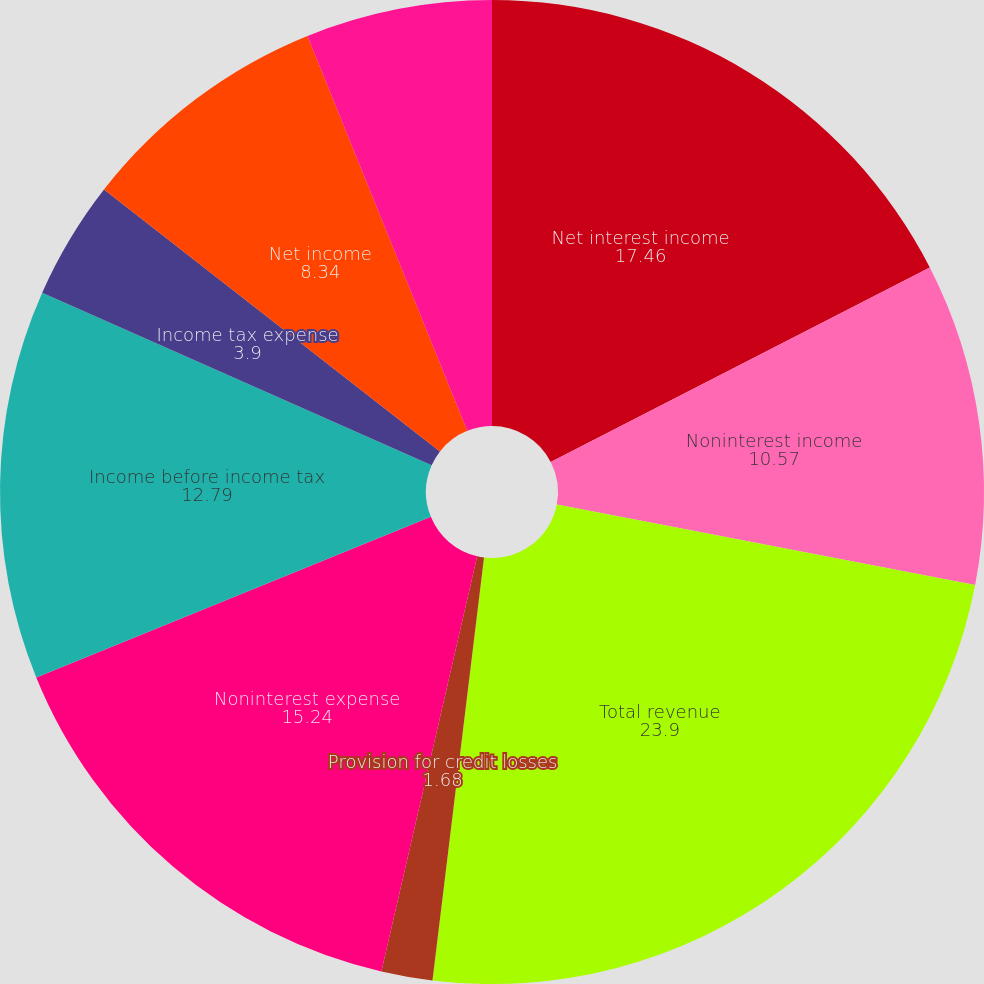<chart> <loc_0><loc_0><loc_500><loc_500><pie_chart><fcel>Net interest income<fcel>Noninterest income<fcel>Total revenue<fcel>Provision for credit losses<fcel>Noninterest expense<fcel>Income before income tax<fcel>Income tax expense<fcel>Net income<fcel>Net income available to common<nl><fcel>17.46%<fcel>10.57%<fcel>23.9%<fcel>1.68%<fcel>15.24%<fcel>12.79%<fcel>3.9%<fcel>8.34%<fcel>6.12%<nl></chart> 